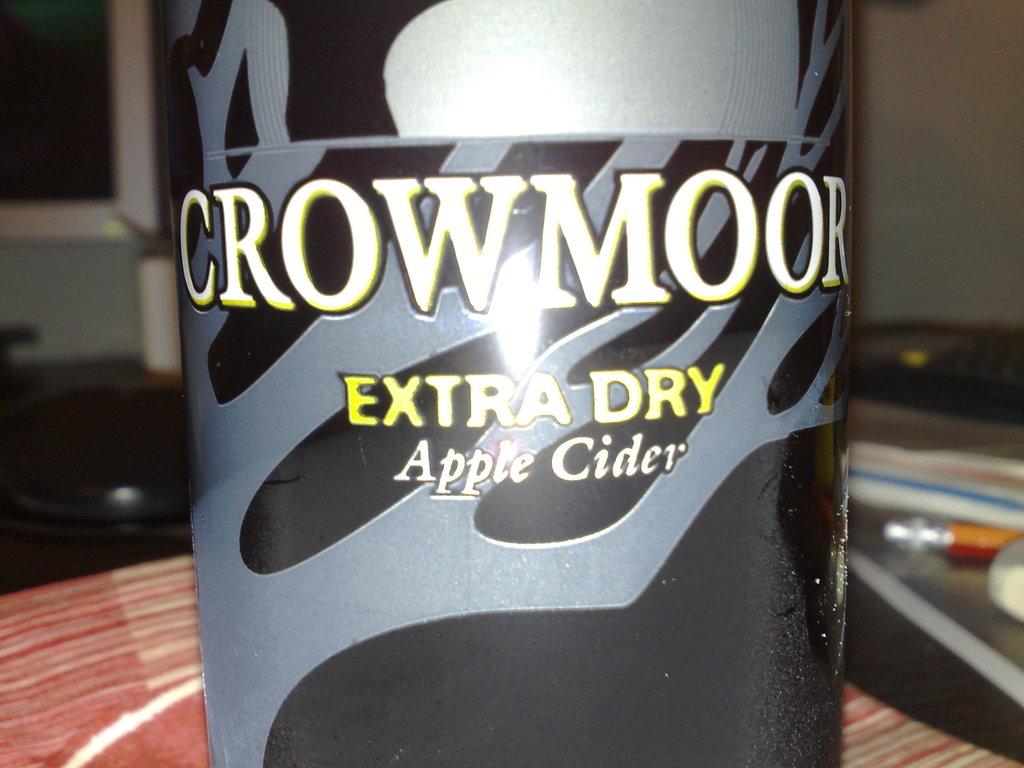What beverage is this?
Give a very brief answer. Apple cider. Where is that drink made from?
Provide a succinct answer. Apple cider. 